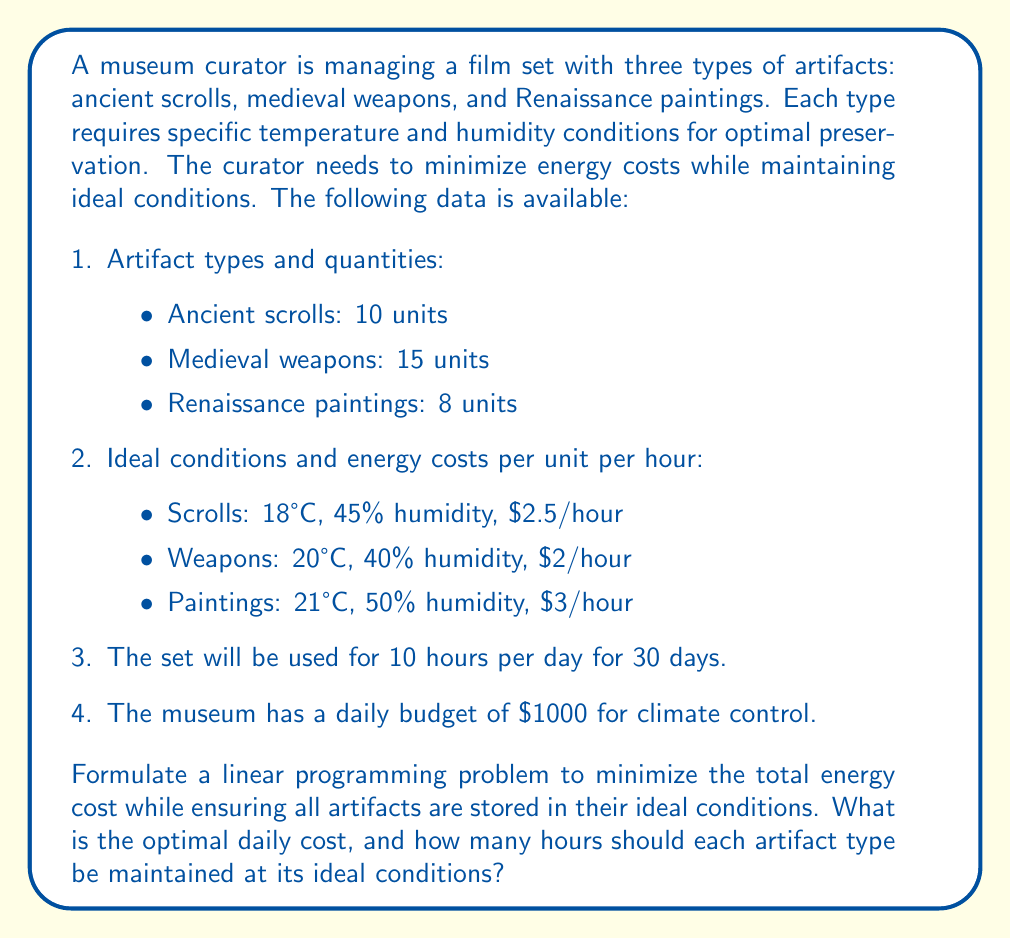Can you solve this math problem? To solve this problem, we need to formulate a linear programming model. Let's define our variables:

$x_1$ = hours per day scrolls are kept at ideal conditions
$x_2$ = hours per day weapons are kept at ideal conditions
$x_3$ = hours per day paintings are kept at ideal conditions

Objective function:
Minimize total daily cost: $Z = 25x_1 + 30x_2 + 24x_3$

Constraints:
1. All artifacts must be kept at ideal conditions for at least 10 hours per day:
   $x_1 \geq 10$
   $x_2 \geq 10$
   $x_3 \geq 10$

2. The total daily cost must not exceed the budget:
   $25x_1 + 30x_2 + 24x_3 \leq 1000$

3. The maximum number of hours per day is 24:
   $x_1 \leq 24$
   $x_2 \leq 24$
   $x_3 \leq 24$

4. Non-negativity constraints:
   $x_1, x_2, x_3 \geq 0$

To solve this linear programming problem, we can use the simplex method or a solver. The optimal solution is:

$x_1 = 10$ hours
$x_2 = 10$ hours
$x_3 = 10$ hours

This means that each artifact type should be kept at its ideal conditions for 10 hours per day, which is the minimum required time.

The optimal daily cost can be calculated by substituting these values into the objective function:

$Z = 25(10) + 30(10) + 24(10) = 250 + 300 + 240 = 790$

Therefore, the optimal daily cost for climate control is $790.
Answer: The optimal daily cost for climate control is $790. Each artifact type (scrolls, weapons, and paintings) should be maintained at its ideal conditions for 10 hours per day. 